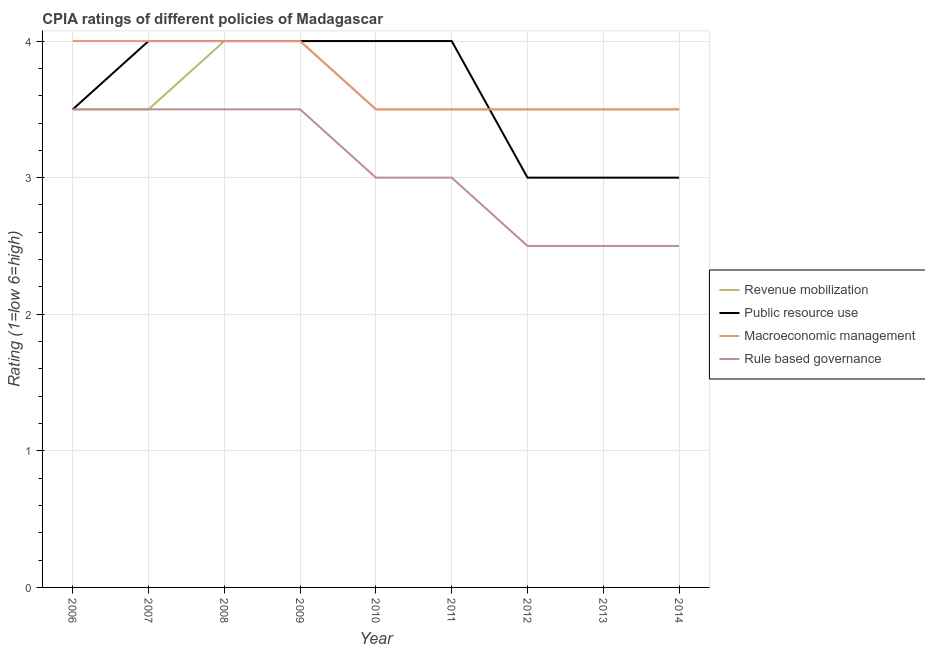How many different coloured lines are there?
Ensure brevity in your answer.  4. Does the line corresponding to cpia rating of revenue mobilization intersect with the line corresponding to cpia rating of macroeconomic management?
Make the answer very short. Yes. In which year was the cpia rating of macroeconomic management maximum?
Offer a very short reply. 2006. In which year was the cpia rating of public resource use minimum?
Offer a terse response. 2012. What is the total cpia rating of macroeconomic management in the graph?
Your response must be concise. 33.5. What is the difference between the cpia rating of public resource use in 2014 and the cpia rating of revenue mobilization in 2010?
Make the answer very short. -0.5. What is the average cpia rating of macroeconomic management per year?
Your answer should be compact. 3.72. Is the difference between the cpia rating of public resource use in 2006 and 2014 greater than the difference between the cpia rating of rule based governance in 2006 and 2014?
Give a very brief answer. No. What is the difference between the highest and the second highest cpia rating of revenue mobilization?
Provide a succinct answer. 0. In how many years, is the cpia rating of macroeconomic management greater than the average cpia rating of macroeconomic management taken over all years?
Keep it short and to the point. 4. Is it the case that in every year, the sum of the cpia rating of macroeconomic management and cpia rating of revenue mobilization is greater than the sum of cpia rating of rule based governance and cpia rating of public resource use?
Keep it short and to the point. Yes. Is the cpia rating of revenue mobilization strictly less than the cpia rating of rule based governance over the years?
Provide a succinct answer. No. How many years are there in the graph?
Your answer should be very brief. 9. What is the difference between two consecutive major ticks on the Y-axis?
Keep it short and to the point. 1. How are the legend labels stacked?
Your answer should be compact. Vertical. What is the title of the graph?
Keep it short and to the point. CPIA ratings of different policies of Madagascar. What is the label or title of the Y-axis?
Offer a terse response. Rating (1=low 6=high). What is the Rating (1=low 6=high) of Public resource use in 2006?
Offer a very short reply. 3.5. What is the Rating (1=low 6=high) in Macroeconomic management in 2006?
Give a very brief answer. 4. What is the Rating (1=low 6=high) of Revenue mobilization in 2007?
Offer a terse response. 3.5. What is the Rating (1=low 6=high) of Macroeconomic management in 2007?
Ensure brevity in your answer.  4. What is the Rating (1=low 6=high) in Rule based governance in 2008?
Your answer should be compact. 3.5. What is the Rating (1=low 6=high) of Rule based governance in 2009?
Your answer should be very brief. 3.5. What is the Rating (1=low 6=high) of Public resource use in 2010?
Give a very brief answer. 4. What is the Rating (1=low 6=high) of Rule based governance in 2010?
Keep it short and to the point. 3. What is the Rating (1=low 6=high) in Public resource use in 2012?
Keep it short and to the point. 3. What is the Rating (1=low 6=high) in Revenue mobilization in 2013?
Provide a short and direct response. 3.5. What is the Rating (1=low 6=high) in Public resource use in 2013?
Provide a short and direct response. 3. What is the Rating (1=low 6=high) of Macroeconomic management in 2013?
Ensure brevity in your answer.  3.5. What is the Rating (1=low 6=high) in Rule based governance in 2013?
Offer a very short reply. 2.5. What is the Rating (1=low 6=high) of Revenue mobilization in 2014?
Ensure brevity in your answer.  3.5. What is the Rating (1=low 6=high) of Rule based governance in 2014?
Offer a terse response. 2.5. Across all years, what is the maximum Rating (1=low 6=high) in Revenue mobilization?
Provide a short and direct response. 4. Across all years, what is the maximum Rating (1=low 6=high) in Public resource use?
Keep it short and to the point. 4. Across all years, what is the minimum Rating (1=low 6=high) in Revenue mobilization?
Your answer should be very brief. 3.5. Across all years, what is the minimum Rating (1=low 6=high) of Public resource use?
Make the answer very short. 3. Across all years, what is the minimum Rating (1=low 6=high) in Macroeconomic management?
Offer a very short reply. 3.5. What is the total Rating (1=low 6=high) of Revenue mobilization in the graph?
Make the answer very short. 32.5. What is the total Rating (1=low 6=high) of Public resource use in the graph?
Offer a terse response. 32.5. What is the total Rating (1=low 6=high) of Macroeconomic management in the graph?
Your answer should be very brief. 33.5. What is the total Rating (1=low 6=high) in Rule based governance in the graph?
Offer a terse response. 27.5. What is the difference between the Rating (1=low 6=high) of Revenue mobilization in 2006 and that in 2007?
Offer a terse response. 0. What is the difference between the Rating (1=low 6=high) in Macroeconomic management in 2006 and that in 2007?
Provide a short and direct response. 0. What is the difference between the Rating (1=low 6=high) of Revenue mobilization in 2006 and that in 2008?
Your response must be concise. -0.5. What is the difference between the Rating (1=low 6=high) in Public resource use in 2006 and that in 2008?
Provide a short and direct response. -0.5. What is the difference between the Rating (1=low 6=high) of Rule based governance in 2006 and that in 2008?
Make the answer very short. 0. What is the difference between the Rating (1=low 6=high) in Revenue mobilization in 2006 and that in 2009?
Keep it short and to the point. -0.5. What is the difference between the Rating (1=low 6=high) in Public resource use in 2006 and that in 2009?
Your answer should be compact. -0.5. What is the difference between the Rating (1=low 6=high) of Revenue mobilization in 2006 and that in 2010?
Ensure brevity in your answer.  0. What is the difference between the Rating (1=low 6=high) of Public resource use in 2006 and that in 2010?
Make the answer very short. -0.5. What is the difference between the Rating (1=low 6=high) in Macroeconomic management in 2006 and that in 2010?
Ensure brevity in your answer.  0.5. What is the difference between the Rating (1=low 6=high) of Rule based governance in 2006 and that in 2010?
Provide a succinct answer. 0.5. What is the difference between the Rating (1=low 6=high) of Public resource use in 2006 and that in 2011?
Offer a very short reply. -0.5. What is the difference between the Rating (1=low 6=high) in Macroeconomic management in 2006 and that in 2011?
Your response must be concise. 0.5. What is the difference between the Rating (1=low 6=high) in Rule based governance in 2006 and that in 2011?
Keep it short and to the point. 0.5. What is the difference between the Rating (1=low 6=high) of Public resource use in 2006 and that in 2012?
Provide a succinct answer. 0.5. What is the difference between the Rating (1=low 6=high) of Revenue mobilization in 2006 and that in 2013?
Offer a very short reply. 0. What is the difference between the Rating (1=low 6=high) of Public resource use in 2006 and that in 2013?
Make the answer very short. 0.5. What is the difference between the Rating (1=low 6=high) of Revenue mobilization in 2006 and that in 2014?
Your answer should be very brief. 0. What is the difference between the Rating (1=low 6=high) of Macroeconomic management in 2006 and that in 2014?
Your answer should be very brief. 0.5. What is the difference between the Rating (1=low 6=high) of Public resource use in 2007 and that in 2008?
Make the answer very short. 0. What is the difference between the Rating (1=low 6=high) of Macroeconomic management in 2007 and that in 2008?
Give a very brief answer. 0. What is the difference between the Rating (1=low 6=high) of Rule based governance in 2007 and that in 2008?
Provide a succinct answer. 0. What is the difference between the Rating (1=low 6=high) of Revenue mobilization in 2007 and that in 2009?
Your response must be concise. -0.5. What is the difference between the Rating (1=low 6=high) of Public resource use in 2007 and that in 2009?
Offer a terse response. 0. What is the difference between the Rating (1=low 6=high) in Macroeconomic management in 2007 and that in 2009?
Your response must be concise. 0. What is the difference between the Rating (1=low 6=high) in Rule based governance in 2007 and that in 2009?
Keep it short and to the point. 0. What is the difference between the Rating (1=low 6=high) in Public resource use in 2007 and that in 2012?
Ensure brevity in your answer.  1. What is the difference between the Rating (1=low 6=high) of Rule based governance in 2007 and that in 2012?
Ensure brevity in your answer.  1. What is the difference between the Rating (1=low 6=high) of Public resource use in 2007 and that in 2013?
Your response must be concise. 1. What is the difference between the Rating (1=low 6=high) in Macroeconomic management in 2007 and that in 2013?
Provide a short and direct response. 0.5. What is the difference between the Rating (1=low 6=high) in Rule based governance in 2007 and that in 2013?
Your answer should be compact. 1. What is the difference between the Rating (1=low 6=high) of Revenue mobilization in 2008 and that in 2009?
Provide a short and direct response. 0. What is the difference between the Rating (1=low 6=high) in Public resource use in 2008 and that in 2009?
Offer a very short reply. 0. What is the difference between the Rating (1=low 6=high) in Rule based governance in 2008 and that in 2009?
Offer a terse response. 0. What is the difference between the Rating (1=low 6=high) of Public resource use in 2008 and that in 2010?
Make the answer very short. 0. What is the difference between the Rating (1=low 6=high) of Macroeconomic management in 2008 and that in 2010?
Make the answer very short. 0.5. What is the difference between the Rating (1=low 6=high) of Rule based governance in 2008 and that in 2010?
Make the answer very short. 0.5. What is the difference between the Rating (1=low 6=high) in Revenue mobilization in 2008 and that in 2011?
Provide a short and direct response. 0.5. What is the difference between the Rating (1=low 6=high) in Macroeconomic management in 2008 and that in 2011?
Provide a succinct answer. 0.5. What is the difference between the Rating (1=low 6=high) in Public resource use in 2008 and that in 2012?
Your answer should be very brief. 1. What is the difference between the Rating (1=low 6=high) of Rule based governance in 2008 and that in 2012?
Provide a short and direct response. 1. What is the difference between the Rating (1=low 6=high) of Revenue mobilization in 2008 and that in 2014?
Give a very brief answer. 0.5. What is the difference between the Rating (1=low 6=high) in Public resource use in 2008 and that in 2014?
Ensure brevity in your answer.  1. What is the difference between the Rating (1=low 6=high) of Revenue mobilization in 2009 and that in 2010?
Provide a succinct answer. 0.5. What is the difference between the Rating (1=low 6=high) of Revenue mobilization in 2009 and that in 2011?
Provide a short and direct response. 0.5. What is the difference between the Rating (1=low 6=high) in Macroeconomic management in 2009 and that in 2011?
Keep it short and to the point. 0.5. What is the difference between the Rating (1=low 6=high) of Revenue mobilization in 2009 and that in 2012?
Your answer should be very brief. 0.5. What is the difference between the Rating (1=low 6=high) in Public resource use in 2009 and that in 2012?
Give a very brief answer. 1. What is the difference between the Rating (1=low 6=high) of Rule based governance in 2009 and that in 2012?
Provide a short and direct response. 1. What is the difference between the Rating (1=low 6=high) in Revenue mobilization in 2009 and that in 2013?
Your answer should be very brief. 0.5. What is the difference between the Rating (1=low 6=high) in Public resource use in 2009 and that in 2013?
Your answer should be compact. 1. What is the difference between the Rating (1=low 6=high) in Rule based governance in 2009 and that in 2013?
Ensure brevity in your answer.  1. What is the difference between the Rating (1=low 6=high) of Macroeconomic management in 2009 and that in 2014?
Give a very brief answer. 0.5. What is the difference between the Rating (1=low 6=high) of Revenue mobilization in 2010 and that in 2011?
Offer a terse response. 0. What is the difference between the Rating (1=low 6=high) of Macroeconomic management in 2010 and that in 2011?
Offer a terse response. 0. What is the difference between the Rating (1=low 6=high) in Revenue mobilization in 2010 and that in 2012?
Your answer should be very brief. 0. What is the difference between the Rating (1=low 6=high) of Macroeconomic management in 2010 and that in 2012?
Make the answer very short. 0. What is the difference between the Rating (1=low 6=high) of Rule based governance in 2010 and that in 2012?
Offer a very short reply. 0.5. What is the difference between the Rating (1=low 6=high) in Macroeconomic management in 2010 and that in 2013?
Provide a short and direct response. 0. What is the difference between the Rating (1=low 6=high) in Revenue mobilization in 2010 and that in 2014?
Provide a short and direct response. 0. What is the difference between the Rating (1=low 6=high) in Public resource use in 2010 and that in 2014?
Give a very brief answer. 1. What is the difference between the Rating (1=low 6=high) of Macroeconomic management in 2010 and that in 2014?
Offer a terse response. 0. What is the difference between the Rating (1=low 6=high) of Rule based governance in 2010 and that in 2014?
Ensure brevity in your answer.  0.5. What is the difference between the Rating (1=low 6=high) of Revenue mobilization in 2011 and that in 2012?
Make the answer very short. 0. What is the difference between the Rating (1=low 6=high) of Public resource use in 2011 and that in 2012?
Make the answer very short. 1. What is the difference between the Rating (1=low 6=high) of Macroeconomic management in 2011 and that in 2012?
Offer a terse response. 0. What is the difference between the Rating (1=low 6=high) in Rule based governance in 2011 and that in 2012?
Provide a succinct answer. 0.5. What is the difference between the Rating (1=low 6=high) of Rule based governance in 2011 and that in 2013?
Ensure brevity in your answer.  0.5. What is the difference between the Rating (1=low 6=high) of Macroeconomic management in 2011 and that in 2014?
Your answer should be compact. 0. What is the difference between the Rating (1=low 6=high) in Macroeconomic management in 2012 and that in 2013?
Keep it short and to the point. 0. What is the difference between the Rating (1=low 6=high) in Public resource use in 2012 and that in 2014?
Your response must be concise. 0. What is the difference between the Rating (1=low 6=high) in Revenue mobilization in 2013 and that in 2014?
Give a very brief answer. 0. What is the difference between the Rating (1=low 6=high) of Public resource use in 2013 and that in 2014?
Offer a terse response. 0. What is the difference between the Rating (1=low 6=high) of Rule based governance in 2013 and that in 2014?
Your answer should be very brief. 0. What is the difference between the Rating (1=low 6=high) in Revenue mobilization in 2006 and the Rating (1=low 6=high) in Public resource use in 2007?
Give a very brief answer. -0.5. What is the difference between the Rating (1=low 6=high) in Revenue mobilization in 2006 and the Rating (1=low 6=high) in Macroeconomic management in 2007?
Offer a terse response. -0.5. What is the difference between the Rating (1=low 6=high) in Macroeconomic management in 2006 and the Rating (1=low 6=high) in Rule based governance in 2007?
Your answer should be very brief. 0.5. What is the difference between the Rating (1=low 6=high) of Revenue mobilization in 2006 and the Rating (1=low 6=high) of Public resource use in 2008?
Make the answer very short. -0.5. What is the difference between the Rating (1=low 6=high) of Revenue mobilization in 2006 and the Rating (1=low 6=high) of Macroeconomic management in 2008?
Provide a short and direct response. -0.5. What is the difference between the Rating (1=low 6=high) of Public resource use in 2006 and the Rating (1=low 6=high) of Macroeconomic management in 2008?
Your response must be concise. -0.5. What is the difference between the Rating (1=low 6=high) of Public resource use in 2006 and the Rating (1=low 6=high) of Rule based governance in 2008?
Your response must be concise. 0. What is the difference between the Rating (1=low 6=high) of Macroeconomic management in 2006 and the Rating (1=low 6=high) of Rule based governance in 2008?
Your answer should be compact. 0.5. What is the difference between the Rating (1=low 6=high) of Revenue mobilization in 2006 and the Rating (1=low 6=high) of Macroeconomic management in 2009?
Your answer should be very brief. -0.5. What is the difference between the Rating (1=low 6=high) in Revenue mobilization in 2006 and the Rating (1=low 6=high) in Macroeconomic management in 2011?
Your answer should be very brief. 0. What is the difference between the Rating (1=low 6=high) of Revenue mobilization in 2006 and the Rating (1=low 6=high) of Rule based governance in 2011?
Keep it short and to the point. 0.5. What is the difference between the Rating (1=low 6=high) in Public resource use in 2006 and the Rating (1=low 6=high) in Macroeconomic management in 2011?
Provide a succinct answer. 0. What is the difference between the Rating (1=low 6=high) in Revenue mobilization in 2006 and the Rating (1=low 6=high) in Public resource use in 2012?
Your answer should be compact. 0.5. What is the difference between the Rating (1=low 6=high) of Revenue mobilization in 2006 and the Rating (1=low 6=high) of Macroeconomic management in 2012?
Offer a terse response. 0. What is the difference between the Rating (1=low 6=high) of Revenue mobilization in 2006 and the Rating (1=low 6=high) of Rule based governance in 2012?
Provide a short and direct response. 1. What is the difference between the Rating (1=low 6=high) in Public resource use in 2006 and the Rating (1=low 6=high) in Macroeconomic management in 2012?
Provide a short and direct response. 0. What is the difference between the Rating (1=low 6=high) of Public resource use in 2006 and the Rating (1=low 6=high) of Rule based governance in 2012?
Make the answer very short. 1. What is the difference between the Rating (1=low 6=high) of Macroeconomic management in 2006 and the Rating (1=low 6=high) of Rule based governance in 2012?
Offer a very short reply. 1.5. What is the difference between the Rating (1=low 6=high) in Revenue mobilization in 2006 and the Rating (1=low 6=high) in Public resource use in 2013?
Provide a short and direct response. 0.5. What is the difference between the Rating (1=low 6=high) of Macroeconomic management in 2006 and the Rating (1=low 6=high) of Rule based governance in 2013?
Give a very brief answer. 1.5. What is the difference between the Rating (1=low 6=high) of Revenue mobilization in 2006 and the Rating (1=low 6=high) of Macroeconomic management in 2014?
Offer a very short reply. 0. What is the difference between the Rating (1=low 6=high) of Revenue mobilization in 2006 and the Rating (1=low 6=high) of Rule based governance in 2014?
Make the answer very short. 1. What is the difference between the Rating (1=low 6=high) of Public resource use in 2006 and the Rating (1=low 6=high) of Macroeconomic management in 2014?
Keep it short and to the point. 0. What is the difference between the Rating (1=low 6=high) in Public resource use in 2006 and the Rating (1=low 6=high) in Rule based governance in 2014?
Your answer should be compact. 1. What is the difference between the Rating (1=low 6=high) in Revenue mobilization in 2007 and the Rating (1=low 6=high) in Public resource use in 2008?
Keep it short and to the point. -0.5. What is the difference between the Rating (1=low 6=high) of Public resource use in 2007 and the Rating (1=low 6=high) of Macroeconomic management in 2008?
Provide a succinct answer. 0. What is the difference between the Rating (1=low 6=high) in Public resource use in 2007 and the Rating (1=low 6=high) in Rule based governance in 2008?
Your response must be concise. 0.5. What is the difference between the Rating (1=low 6=high) in Macroeconomic management in 2007 and the Rating (1=low 6=high) in Rule based governance in 2008?
Provide a succinct answer. 0.5. What is the difference between the Rating (1=low 6=high) of Revenue mobilization in 2007 and the Rating (1=low 6=high) of Public resource use in 2009?
Provide a short and direct response. -0.5. What is the difference between the Rating (1=low 6=high) in Revenue mobilization in 2007 and the Rating (1=low 6=high) in Macroeconomic management in 2009?
Ensure brevity in your answer.  -0.5. What is the difference between the Rating (1=low 6=high) of Public resource use in 2007 and the Rating (1=low 6=high) of Macroeconomic management in 2009?
Offer a terse response. 0. What is the difference between the Rating (1=low 6=high) of Public resource use in 2007 and the Rating (1=low 6=high) of Rule based governance in 2009?
Your response must be concise. 0.5. What is the difference between the Rating (1=low 6=high) of Macroeconomic management in 2007 and the Rating (1=low 6=high) of Rule based governance in 2009?
Offer a very short reply. 0.5. What is the difference between the Rating (1=low 6=high) of Revenue mobilization in 2007 and the Rating (1=low 6=high) of Public resource use in 2010?
Your response must be concise. -0.5. What is the difference between the Rating (1=low 6=high) in Public resource use in 2007 and the Rating (1=low 6=high) in Rule based governance in 2010?
Your answer should be very brief. 1. What is the difference between the Rating (1=low 6=high) of Macroeconomic management in 2007 and the Rating (1=low 6=high) of Rule based governance in 2010?
Your answer should be compact. 1. What is the difference between the Rating (1=low 6=high) of Revenue mobilization in 2007 and the Rating (1=low 6=high) of Macroeconomic management in 2011?
Provide a succinct answer. 0. What is the difference between the Rating (1=low 6=high) of Revenue mobilization in 2007 and the Rating (1=low 6=high) of Rule based governance in 2011?
Your answer should be very brief. 0.5. What is the difference between the Rating (1=low 6=high) in Revenue mobilization in 2007 and the Rating (1=low 6=high) in Public resource use in 2012?
Offer a very short reply. 0.5. What is the difference between the Rating (1=low 6=high) of Revenue mobilization in 2007 and the Rating (1=low 6=high) of Macroeconomic management in 2012?
Ensure brevity in your answer.  0. What is the difference between the Rating (1=low 6=high) in Public resource use in 2007 and the Rating (1=low 6=high) in Macroeconomic management in 2012?
Keep it short and to the point. 0.5. What is the difference between the Rating (1=low 6=high) in Public resource use in 2007 and the Rating (1=low 6=high) in Rule based governance in 2012?
Provide a short and direct response. 1.5. What is the difference between the Rating (1=low 6=high) of Revenue mobilization in 2007 and the Rating (1=low 6=high) of Rule based governance in 2013?
Offer a very short reply. 1. What is the difference between the Rating (1=low 6=high) in Public resource use in 2007 and the Rating (1=low 6=high) in Macroeconomic management in 2014?
Offer a very short reply. 0.5. What is the difference between the Rating (1=low 6=high) in Macroeconomic management in 2007 and the Rating (1=low 6=high) in Rule based governance in 2014?
Ensure brevity in your answer.  1.5. What is the difference between the Rating (1=low 6=high) in Revenue mobilization in 2008 and the Rating (1=low 6=high) in Public resource use in 2009?
Make the answer very short. 0. What is the difference between the Rating (1=low 6=high) of Revenue mobilization in 2008 and the Rating (1=low 6=high) of Macroeconomic management in 2009?
Provide a succinct answer. 0. What is the difference between the Rating (1=low 6=high) of Revenue mobilization in 2008 and the Rating (1=low 6=high) of Rule based governance in 2009?
Your answer should be very brief. 0.5. What is the difference between the Rating (1=low 6=high) of Revenue mobilization in 2008 and the Rating (1=low 6=high) of Public resource use in 2010?
Provide a succinct answer. 0. What is the difference between the Rating (1=low 6=high) in Revenue mobilization in 2008 and the Rating (1=low 6=high) in Macroeconomic management in 2010?
Offer a terse response. 0.5. What is the difference between the Rating (1=low 6=high) in Revenue mobilization in 2008 and the Rating (1=low 6=high) in Rule based governance in 2010?
Provide a succinct answer. 1. What is the difference between the Rating (1=low 6=high) of Public resource use in 2008 and the Rating (1=low 6=high) of Rule based governance in 2010?
Your response must be concise. 1. What is the difference between the Rating (1=low 6=high) of Macroeconomic management in 2008 and the Rating (1=low 6=high) of Rule based governance in 2010?
Provide a succinct answer. 1. What is the difference between the Rating (1=low 6=high) of Revenue mobilization in 2008 and the Rating (1=low 6=high) of Public resource use in 2011?
Give a very brief answer. 0. What is the difference between the Rating (1=low 6=high) of Public resource use in 2008 and the Rating (1=low 6=high) of Macroeconomic management in 2011?
Provide a succinct answer. 0.5. What is the difference between the Rating (1=low 6=high) of Public resource use in 2008 and the Rating (1=low 6=high) of Rule based governance in 2011?
Ensure brevity in your answer.  1. What is the difference between the Rating (1=low 6=high) in Public resource use in 2008 and the Rating (1=low 6=high) in Macroeconomic management in 2012?
Your answer should be very brief. 0.5. What is the difference between the Rating (1=low 6=high) in Public resource use in 2008 and the Rating (1=low 6=high) in Rule based governance in 2012?
Provide a succinct answer. 1.5. What is the difference between the Rating (1=low 6=high) of Macroeconomic management in 2008 and the Rating (1=low 6=high) of Rule based governance in 2012?
Offer a very short reply. 1.5. What is the difference between the Rating (1=low 6=high) in Revenue mobilization in 2008 and the Rating (1=low 6=high) in Rule based governance in 2013?
Your response must be concise. 1.5. What is the difference between the Rating (1=low 6=high) in Public resource use in 2008 and the Rating (1=low 6=high) in Rule based governance in 2013?
Provide a short and direct response. 1.5. What is the difference between the Rating (1=low 6=high) of Revenue mobilization in 2008 and the Rating (1=low 6=high) of Public resource use in 2014?
Provide a succinct answer. 1. What is the difference between the Rating (1=low 6=high) of Macroeconomic management in 2008 and the Rating (1=low 6=high) of Rule based governance in 2014?
Provide a short and direct response. 1.5. What is the difference between the Rating (1=low 6=high) in Revenue mobilization in 2009 and the Rating (1=low 6=high) in Public resource use in 2010?
Provide a short and direct response. 0. What is the difference between the Rating (1=low 6=high) in Revenue mobilization in 2009 and the Rating (1=low 6=high) in Macroeconomic management in 2010?
Keep it short and to the point. 0.5. What is the difference between the Rating (1=low 6=high) in Revenue mobilization in 2009 and the Rating (1=low 6=high) in Rule based governance in 2010?
Offer a very short reply. 1. What is the difference between the Rating (1=low 6=high) of Public resource use in 2009 and the Rating (1=low 6=high) of Macroeconomic management in 2010?
Provide a succinct answer. 0.5. What is the difference between the Rating (1=low 6=high) in Public resource use in 2009 and the Rating (1=low 6=high) in Rule based governance in 2010?
Your answer should be compact. 1. What is the difference between the Rating (1=low 6=high) of Macroeconomic management in 2009 and the Rating (1=low 6=high) of Rule based governance in 2010?
Keep it short and to the point. 1. What is the difference between the Rating (1=low 6=high) of Revenue mobilization in 2009 and the Rating (1=low 6=high) of Public resource use in 2011?
Your answer should be compact. 0. What is the difference between the Rating (1=low 6=high) of Revenue mobilization in 2009 and the Rating (1=low 6=high) of Macroeconomic management in 2011?
Your answer should be very brief. 0.5. What is the difference between the Rating (1=low 6=high) of Revenue mobilization in 2009 and the Rating (1=low 6=high) of Rule based governance in 2011?
Your response must be concise. 1. What is the difference between the Rating (1=low 6=high) in Public resource use in 2009 and the Rating (1=low 6=high) in Macroeconomic management in 2011?
Provide a succinct answer. 0.5. What is the difference between the Rating (1=low 6=high) in Public resource use in 2009 and the Rating (1=low 6=high) in Rule based governance in 2011?
Your response must be concise. 1. What is the difference between the Rating (1=low 6=high) of Macroeconomic management in 2009 and the Rating (1=low 6=high) of Rule based governance in 2011?
Offer a very short reply. 1. What is the difference between the Rating (1=low 6=high) of Revenue mobilization in 2009 and the Rating (1=low 6=high) of Public resource use in 2012?
Provide a succinct answer. 1. What is the difference between the Rating (1=low 6=high) of Revenue mobilization in 2009 and the Rating (1=low 6=high) of Macroeconomic management in 2012?
Your answer should be compact. 0.5. What is the difference between the Rating (1=low 6=high) of Revenue mobilization in 2009 and the Rating (1=low 6=high) of Rule based governance in 2012?
Make the answer very short. 1.5. What is the difference between the Rating (1=low 6=high) of Public resource use in 2009 and the Rating (1=low 6=high) of Macroeconomic management in 2012?
Your response must be concise. 0.5. What is the difference between the Rating (1=low 6=high) in Macroeconomic management in 2009 and the Rating (1=low 6=high) in Rule based governance in 2012?
Provide a short and direct response. 1.5. What is the difference between the Rating (1=low 6=high) in Revenue mobilization in 2009 and the Rating (1=low 6=high) in Rule based governance in 2013?
Provide a succinct answer. 1.5. What is the difference between the Rating (1=low 6=high) in Public resource use in 2009 and the Rating (1=low 6=high) in Macroeconomic management in 2013?
Make the answer very short. 0.5. What is the difference between the Rating (1=low 6=high) in Revenue mobilization in 2009 and the Rating (1=low 6=high) in Public resource use in 2014?
Ensure brevity in your answer.  1. What is the difference between the Rating (1=low 6=high) in Public resource use in 2009 and the Rating (1=low 6=high) in Macroeconomic management in 2014?
Your answer should be very brief. 0.5. What is the difference between the Rating (1=low 6=high) of Macroeconomic management in 2009 and the Rating (1=low 6=high) of Rule based governance in 2014?
Make the answer very short. 1.5. What is the difference between the Rating (1=low 6=high) of Revenue mobilization in 2010 and the Rating (1=low 6=high) of Public resource use in 2011?
Provide a short and direct response. -0.5. What is the difference between the Rating (1=low 6=high) of Revenue mobilization in 2010 and the Rating (1=low 6=high) of Macroeconomic management in 2011?
Keep it short and to the point. 0. What is the difference between the Rating (1=low 6=high) in Public resource use in 2010 and the Rating (1=low 6=high) in Rule based governance in 2011?
Your answer should be very brief. 1. What is the difference between the Rating (1=low 6=high) in Macroeconomic management in 2010 and the Rating (1=low 6=high) in Rule based governance in 2011?
Your answer should be compact. 0.5. What is the difference between the Rating (1=low 6=high) of Revenue mobilization in 2010 and the Rating (1=low 6=high) of Public resource use in 2012?
Keep it short and to the point. 0.5. What is the difference between the Rating (1=low 6=high) of Macroeconomic management in 2010 and the Rating (1=low 6=high) of Rule based governance in 2012?
Provide a short and direct response. 1. What is the difference between the Rating (1=low 6=high) in Revenue mobilization in 2010 and the Rating (1=low 6=high) in Rule based governance in 2013?
Offer a terse response. 1. What is the difference between the Rating (1=low 6=high) in Public resource use in 2010 and the Rating (1=low 6=high) in Macroeconomic management in 2013?
Provide a short and direct response. 0.5. What is the difference between the Rating (1=low 6=high) in Revenue mobilization in 2010 and the Rating (1=low 6=high) in Rule based governance in 2014?
Offer a terse response. 1. What is the difference between the Rating (1=low 6=high) in Public resource use in 2010 and the Rating (1=low 6=high) in Rule based governance in 2014?
Provide a succinct answer. 1.5. What is the difference between the Rating (1=low 6=high) in Macroeconomic management in 2010 and the Rating (1=low 6=high) in Rule based governance in 2014?
Your answer should be compact. 1. What is the difference between the Rating (1=low 6=high) of Revenue mobilization in 2011 and the Rating (1=low 6=high) of Macroeconomic management in 2012?
Ensure brevity in your answer.  0. What is the difference between the Rating (1=low 6=high) of Public resource use in 2011 and the Rating (1=low 6=high) of Rule based governance in 2012?
Your answer should be compact. 1.5. What is the difference between the Rating (1=low 6=high) in Revenue mobilization in 2011 and the Rating (1=low 6=high) in Public resource use in 2014?
Provide a succinct answer. 0.5. What is the difference between the Rating (1=low 6=high) in Revenue mobilization in 2011 and the Rating (1=low 6=high) in Macroeconomic management in 2014?
Ensure brevity in your answer.  0. What is the difference between the Rating (1=low 6=high) in Macroeconomic management in 2011 and the Rating (1=low 6=high) in Rule based governance in 2014?
Offer a terse response. 1. What is the difference between the Rating (1=low 6=high) in Macroeconomic management in 2012 and the Rating (1=low 6=high) in Rule based governance in 2013?
Provide a short and direct response. 1. What is the difference between the Rating (1=low 6=high) in Revenue mobilization in 2012 and the Rating (1=low 6=high) in Public resource use in 2014?
Provide a succinct answer. 0.5. What is the difference between the Rating (1=low 6=high) of Revenue mobilization in 2012 and the Rating (1=low 6=high) of Rule based governance in 2014?
Offer a terse response. 1. What is the difference between the Rating (1=low 6=high) of Public resource use in 2012 and the Rating (1=low 6=high) of Rule based governance in 2014?
Ensure brevity in your answer.  0.5. What is the difference between the Rating (1=low 6=high) of Macroeconomic management in 2013 and the Rating (1=low 6=high) of Rule based governance in 2014?
Your answer should be very brief. 1. What is the average Rating (1=low 6=high) in Revenue mobilization per year?
Offer a very short reply. 3.61. What is the average Rating (1=low 6=high) of Public resource use per year?
Keep it short and to the point. 3.61. What is the average Rating (1=low 6=high) of Macroeconomic management per year?
Offer a very short reply. 3.72. What is the average Rating (1=low 6=high) of Rule based governance per year?
Give a very brief answer. 3.06. In the year 2006, what is the difference between the Rating (1=low 6=high) in Revenue mobilization and Rating (1=low 6=high) in Macroeconomic management?
Keep it short and to the point. -0.5. In the year 2006, what is the difference between the Rating (1=low 6=high) of Revenue mobilization and Rating (1=low 6=high) of Rule based governance?
Your response must be concise. 0. In the year 2006, what is the difference between the Rating (1=low 6=high) of Public resource use and Rating (1=low 6=high) of Rule based governance?
Give a very brief answer. 0. In the year 2006, what is the difference between the Rating (1=low 6=high) in Macroeconomic management and Rating (1=low 6=high) in Rule based governance?
Your response must be concise. 0.5. In the year 2007, what is the difference between the Rating (1=low 6=high) of Public resource use and Rating (1=low 6=high) of Macroeconomic management?
Your answer should be compact. 0. In the year 2007, what is the difference between the Rating (1=low 6=high) of Macroeconomic management and Rating (1=low 6=high) of Rule based governance?
Provide a succinct answer. 0.5. In the year 2008, what is the difference between the Rating (1=low 6=high) of Revenue mobilization and Rating (1=low 6=high) of Public resource use?
Your answer should be very brief. 0. In the year 2008, what is the difference between the Rating (1=low 6=high) in Revenue mobilization and Rating (1=low 6=high) in Macroeconomic management?
Provide a succinct answer. 0. In the year 2008, what is the difference between the Rating (1=low 6=high) of Public resource use and Rating (1=low 6=high) of Macroeconomic management?
Provide a short and direct response. 0. In the year 2008, what is the difference between the Rating (1=low 6=high) of Macroeconomic management and Rating (1=low 6=high) of Rule based governance?
Keep it short and to the point. 0.5. In the year 2009, what is the difference between the Rating (1=low 6=high) in Revenue mobilization and Rating (1=low 6=high) in Rule based governance?
Your answer should be compact. 0.5. In the year 2009, what is the difference between the Rating (1=low 6=high) of Public resource use and Rating (1=low 6=high) of Macroeconomic management?
Make the answer very short. 0. In the year 2010, what is the difference between the Rating (1=low 6=high) in Revenue mobilization and Rating (1=low 6=high) in Macroeconomic management?
Your response must be concise. 0. In the year 2010, what is the difference between the Rating (1=low 6=high) of Revenue mobilization and Rating (1=low 6=high) of Rule based governance?
Offer a very short reply. 0.5. In the year 2011, what is the difference between the Rating (1=low 6=high) in Revenue mobilization and Rating (1=low 6=high) in Public resource use?
Provide a succinct answer. -0.5. In the year 2011, what is the difference between the Rating (1=low 6=high) in Revenue mobilization and Rating (1=low 6=high) in Macroeconomic management?
Keep it short and to the point. 0. In the year 2011, what is the difference between the Rating (1=low 6=high) in Public resource use and Rating (1=low 6=high) in Macroeconomic management?
Ensure brevity in your answer.  0.5. In the year 2011, what is the difference between the Rating (1=low 6=high) of Macroeconomic management and Rating (1=low 6=high) of Rule based governance?
Your answer should be compact. 0.5. In the year 2012, what is the difference between the Rating (1=low 6=high) in Revenue mobilization and Rating (1=low 6=high) in Macroeconomic management?
Make the answer very short. 0. In the year 2012, what is the difference between the Rating (1=low 6=high) of Public resource use and Rating (1=low 6=high) of Rule based governance?
Offer a terse response. 0.5. In the year 2013, what is the difference between the Rating (1=low 6=high) in Revenue mobilization and Rating (1=low 6=high) in Rule based governance?
Provide a short and direct response. 1. In the year 2013, what is the difference between the Rating (1=low 6=high) in Public resource use and Rating (1=low 6=high) in Macroeconomic management?
Keep it short and to the point. -0.5. In the year 2014, what is the difference between the Rating (1=low 6=high) of Revenue mobilization and Rating (1=low 6=high) of Public resource use?
Offer a terse response. 0.5. In the year 2014, what is the difference between the Rating (1=low 6=high) of Revenue mobilization and Rating (1=low 6=high) of Macroeconomic management?
Make the answer very short. 0. What is the ratio of the Rating (1=low 6=high) in Revenue mobilization in 2006 to that in 2007?
Offer a terse response. 1. What is the ratio of the Rating (1=low 6=high) in Public resource use in 2006 to that in 2007?
Provide a succinct answer. 0.88. What is the ratio of the Rating (1=low 6=high) in Macroeconomic management in 2006 to that in 2007?
Offer a terse response. 1. What is the ratio of the Rating (1=low 6=high) of Revenue mobilization in 2006 to that in 2008?
Your answer should be very brief. 0.88. What is the ratio of the Rating (1=low 6=high) of Public resource use in 2006 to that in 2008?
Offer a terse response. 0.88. What is the ratio of the Rating (1=low 6=high) of Macroeconomic management in 2006 to that in 2008?
Make the answer very short. 1. What is the ratio of the Rating (1=low 6=high) in Public resource use in 2006 to that in 2009?
Offer a terse response. 0.88. What is the ratio of the Rating (1=low 6=high) of Rule based governance in 2006 to that in 2009?
Ensure brevity in your answer.  1. What is the ratio of the Rating (1=low 6=high) of Public resource use in 2006 to that in 2011?
Your answer should be very brief. 0.88. What is the ratio of the Rating (1=low 6=high) of Macroeconomic management in 2006 to that in 2011?
Your response must be concise. 1.14. What is the ratio of the Rating (1=low 6=high) of Revenue mobilization in 2006 to that in 2013?
Your response must be concise. 1. What is the ratio of the Rating (1=low 6=high) of Public resource use in 2006 to that in 2013?
Your response must be concise. 1.17. What is the ratio of the Rating (1=low 6=high) in Macroeconomic management in 2006 to that in 2013?
Your answer should be very brief. 1.14. What is the ratio of the Rating (1=low 6=high) in Revenue mobilization in 2006 to that in 2014?
Your answer should be very brief. 1. What is the ratio of the Rating (1=low 6=high) of Macroeconomic management in 2006 to that in 2014?
Provide a short and direct response. 1.14. What is the ratio of the Rating (1=low 6=high) in Rule based governance in 2006 to that in 2014?
Keep it short and to the point. 1.4. What is the ratio of the Rating (1=low 6=high) of Rule based governance in 2007 to that in 2008?
Keep it short and to the point. 1. What is the ratio of the Rating (1=low 6=high) of Revenue mobilization in 2007 to that in 2009?
Provide a succinct answer. 0.88. What is the ratio of the Rating (1=low 6=high) in Macroeconomic management in 2007 to that in 2009?
Offer a terse response. 1. What is the ratio of the Rating (1=low 6=high) of Macroeconomic management in 2007 to that in 2010?
Your answer should be compact. 1.14. What is the ratio of the Rating (1=low 6=high) in Rule based governance in 2007 to that in 2010?
Give a very brief answer. 1.17. What is the ratio of the Rating (1=low 6=high) of Revenue mobilization in 2007 to that in 2012?
Your answer should be compact. 1. What is the ratio of the Rating (1=low 6=high) of Revenue mobilization in 2007 to that in 2013?
Give a very brief answer. 1. What is the ratio of the Rating (1=low 6=high) in Macroeconomic management in 2007 to that in 2014?
Give a very brief answer. 1.14. What is the ratio of the Rating (1=low 6=high) in Public resource use in 2008 to that in 2010?
Your answer should be very brief. 1. What is the ratio of the Rating (1=low 6=high) of Revenue mobilization in 2008 to that in 2011?
Provide a short and direct response. 1.14. What is the ratio of the Rating (1=low 6=high) in Public resource use in 2008 to that in 2011?
Your answer should be very brief. 1. What is the ratio of the Rating (1=low 6=high) in Rule based governance in 2008 to that in 2011?
Your response must be concise. 1.17. What is the ratio of the Rating (1=low 6=high) in Revenue mobilization in 2008 to that in 2012?
Your response must be concise. 1.14. What is the ratio of the Rating (1=low 6=high) in Macroeconomic management in 2008 to that in 2012?
Offer a terse response. 1.14. What is the ratio of the Rating (1=low 6=high) in Rule based governance in 2008 to that in 2012?
Offer a terse response. 1.4. What is the ratio of the Rating (1=low 6=high) in Macroeconomic management in 2008 to that in 2013?
Provide a short and direct response. 1.14. What is the ratio of the Rating (1=low 6=high) in Rule based governance in 2008 to that in 2013?
Give a very brief answer. 1.4. What is the ratio of the Rating (1=low 6=high) in Public resource use in 2008 to that in 2014?
Make the answer very short. 1.33. What is the ratio of the Rating (1=low 6=high) of Macroeconomic management in 2008 to that in 2014?
Offer a terse response. 1.14. What is the ratio of the Rating (1=low 6=high) of Revenue mobilization in 2009 to that in 2010?
Offer a very short reply. 1.14. What is the ratio of the Rating (1=low 6=high) in Public resource use in 2009 to that in 2010?
Offer a very short reply. 1. What is the ratio of the Rating (1=low 6=high) in Macroeconomic management in 2009 to that in 2010?
Make the answer very short. 1.14. What is the ratio of the Rating (1=low 6=high) of Revenue mobilization in 2009 to that in 2011?
Offer a very short reply. 1.14. What is the ratio of the Rating (1=low 6=high) in Public resource use in 2009 to that in 2011?
Provide a short and direct response. 1. What is the ratio of the Rating (1=low 6=high) in Rule based governance in 2009 to that in 2011?
Provide a succinct answer. 1.17. What is the ratio of the Rating (1=low 6=high) in Revenue mobilization in 2009 to that in 2012?
Keep it short and to the point. 1.14. What is the ratio of the Rating (1=low 6=high) in Rule based governance in 2009 to that in 2012?
Offer a terse response. 1.4. What is the ratio of the Rating (1=low 6=high) in Revenue mobilization in 2009 to that in 2013?
Your answer should be very brief. 1.14. What is the ratio of the Rating (1=low 6=high) of Public resource use in 2009 to that in 2013?
Give a very brief answer. 1.33. What is the ratio of the Rating (1=low 6=high) of Public resource use in 2009 to that in 2014?
Offer a very short reply. 1.33. What is the ratio of the Rating (1=low 6=high) of Macroeconomic management in 2010 to that in 2011?
Offer a terse response. 1. What is the ratio of the Rating (1=low 6=high) in Macroeconomic management in 2010 to that in 2012?
Your answer should be compact. 1. What is the ratio of the Rating (1=low 6=high) in Revenue mobilization in 2010 to that in 2013?
Offer a terse response. 1. What is the ratio of the Rating (1=low 6=high) in Macroeconomic management in 2010 to that in 2013?
Offer a terse response. 1. What is the ratio of the Rating (1=low 6=high) in Rule based governance in 2010 to that in 2013?
Give a very brief answer. 1.2. What is the ratio of the Rating (1=low 6=high) of Revenue mobilization in 2010 to that in 2014?
Offer a terse response. 1. What is the ratio of the Rating (1=low 6=high) of Public resource use in 2011 to that in 2013?
Your response must be concise. 1.33. What is the ratio of the Rating (1=low 6=high) in Revenue mobilization in 2011 to that in 2014?
Keep it short and to the point. 1. What is the ratio of the Rating (1=low 6=high) of Macroeconomic management in 2011 to that in 2014?
Keep it short and to the point. 1. What is the ratio of the Rating (1=low 6=high) in Revenue mobilization in 2012 to that in 2013?
Keep it short and to the point. 1. What is the ratio of the Rating (1=low 6=high) of Macroeconomic management in 2012 to that in 2013?
Offer a very short reply. 1. What is the ratio of the Rating (1=low 6=high) of Rule based governance in 2012 to that in 2013?
Make the answer very short. 1. What is the ratio of the Rating (1=low 6=high) in Public resource use in 2012 to that in 2014?
Offer a terse response. 1. What is the ratio of the Rating (1=low 6=high) in Rule based governance in 2012 to that in 2014?
Give a very brief answer. 1. What is the ratio of the Rating (1=low 6=high) of Revenue mobilization in 2013 to that in 2014?
Offer a very short reply. 1. What is the ratio of the Rating (1=low 6=high) in Public resource use in 2013 to that in 2014?
Make the answer very short. 1. What is the ratio of the Rating (1=low 6=high) in Rule based governance in 2013 to that in 2014?
Your response must be concise. 1. What is the difference between the highest and the second highest Rating (1=low 6=high) in Macroeconomic management?
Offer a terse response. 0. What is the difference between the highest and the lowest Rating (1=low 6=high) of Revenue mobilization?
Provide a short and direct response. 0.5. What is the difference between the highest and the lowest Rating (1=low 6=high) in Public resource use?
Your answer should be very brief. 1. What is the difference between the highest and the lowest Rating (1=low 6=high) of Macroeconomic management?
Ensure brevity in your answer.  0.5. What is the difference between the highest and the lowest Rating (1=low 6=high) in Rule based governance?
Your response must be concise. 1. 